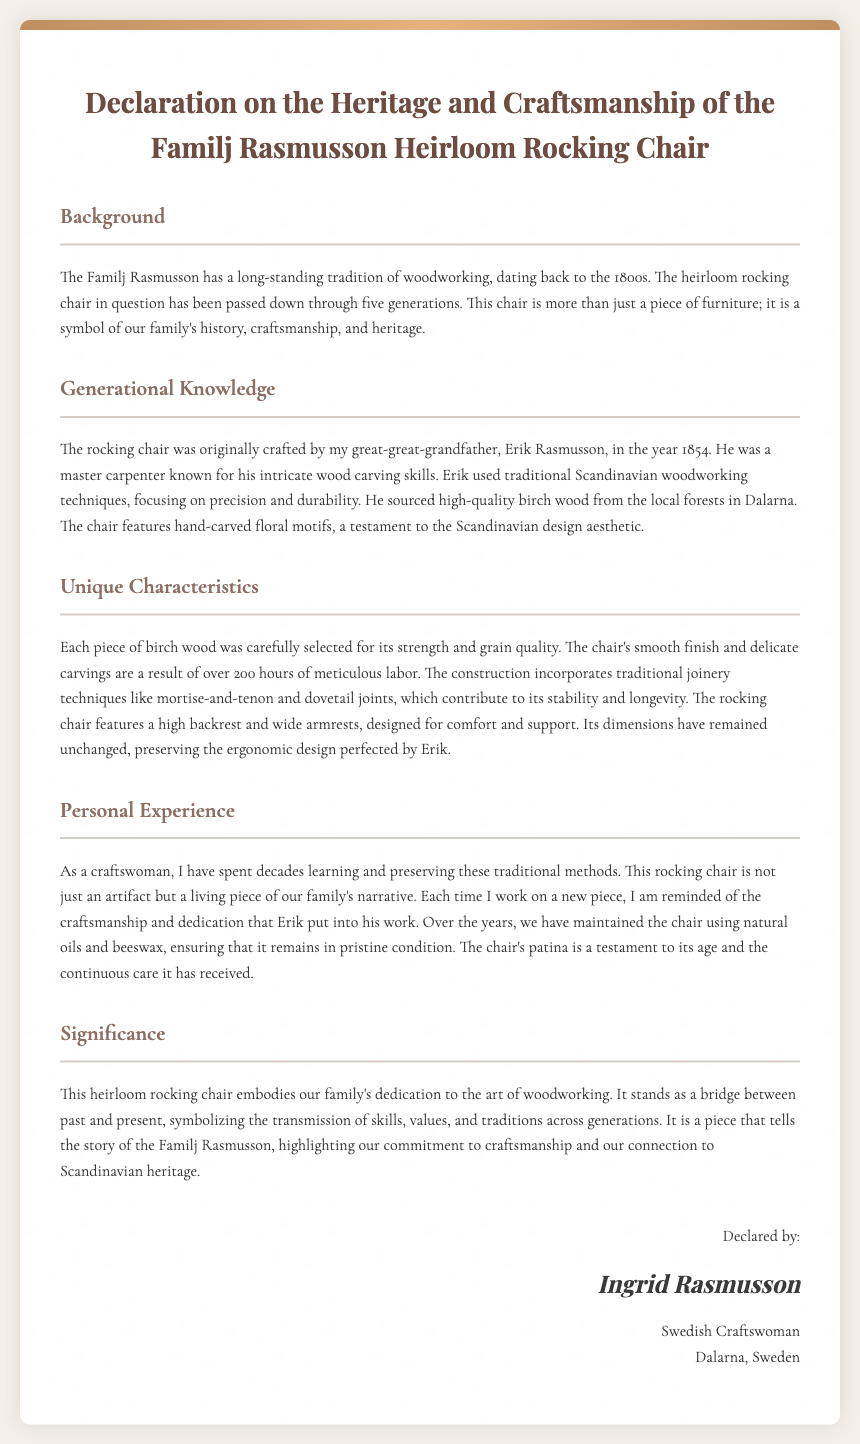What year was the rocking chair originally crafted? The document states that the rocking chair was crafted in the year 1854.
Answer: 1854 Who was the original craftsman of the rocking chair? The declaration mentions that the rocking chair was originally crafted by Erik Rasmusson.
Answer: Erik Rasmusson How many generations has the rocking chair been passed down through? According to the document, the rocking chair has been passed down through five generations.
Answer: five What type of wood was used to craft the rocking chair? The document specifies that high-quality birch wood was used to make the rocking chair.
Answer: birch wood What decorative elements are featured on the rocking chair? The rocking chair features hand-carved floral motifs, representing the Scandinavian design aesthetic.
Answer: hand-carved floral motifs How long did it take to complete the chair's construction? The document states that it took over 200 hours of meticulous labor to complete the chair.
Answer: 200 hours What techniques did Erik Rasmusson use in the chair's construction? The document mentions traditional joinery techniques like mortise-and-tenon and dovetail joints were used.
Answer: mortise-and-tenon and dovetail joints What is the name of the declarant? The declaration indicates that the declarant's name is Ingrid Rasmusson.
Answer: Ingrid Rasmusson What does the rocking chair symbolize for the Familj Rasmusson? The rocking chair symbolizes the family's history, craftsmanship, and heritage according to the document.
Answer: family history and craftsmanship 